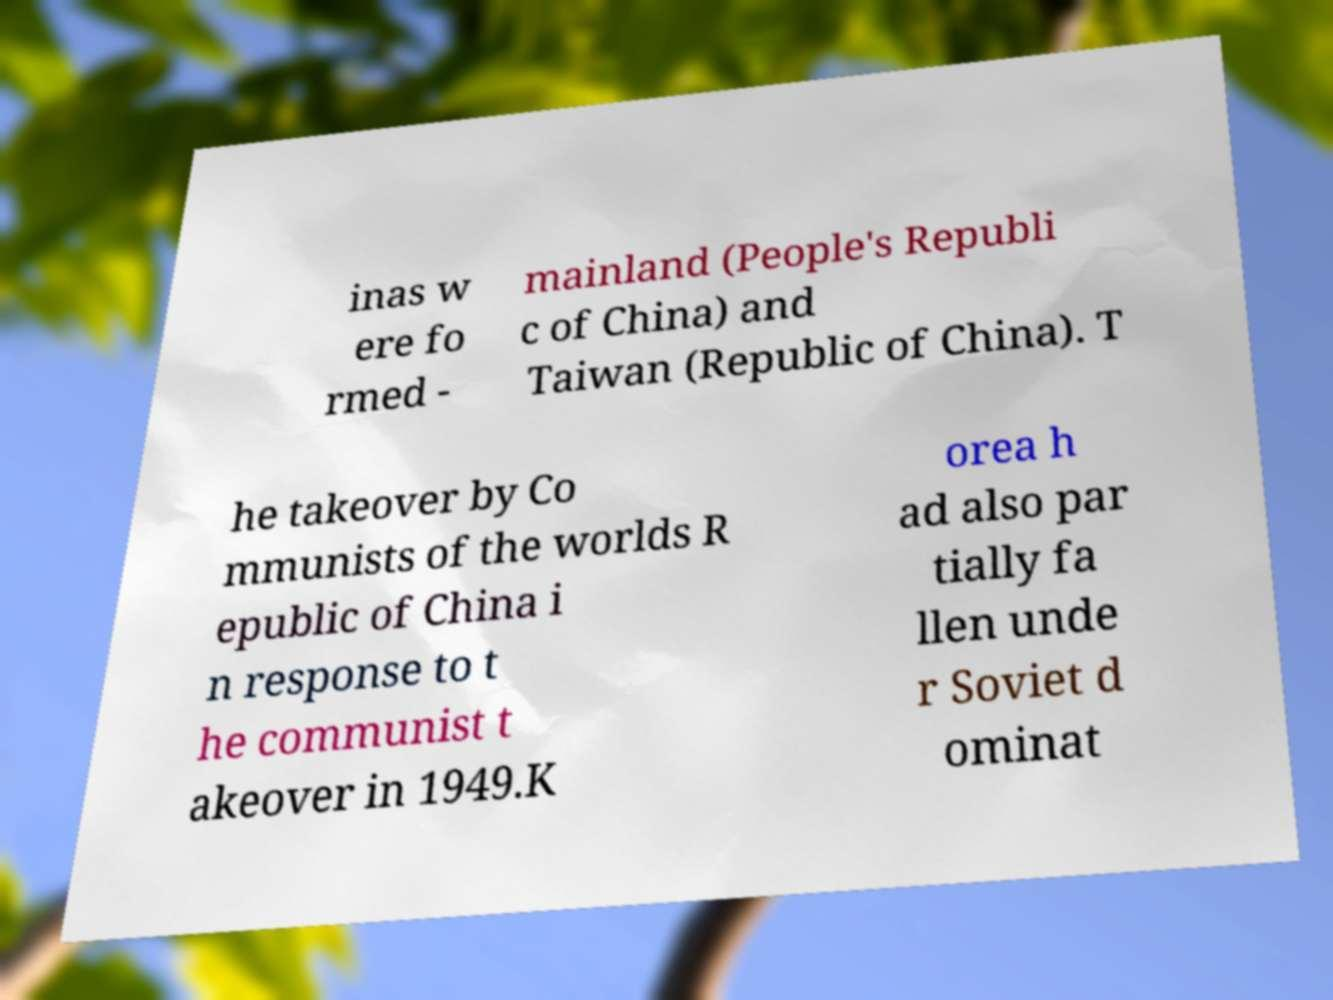Can you read and provide the text displayed in the image?This photo seems to have some interesting text. Can you extract and type it out for me? inas w ere fo rmed - mainland (People's Republi c of China) and Taiwan (Republic of China). T he takeover by Co mmunists of the worlds R epublic of China i n response to t he communist t akeover in 1949.K orea h ad also par tially fa llen unde r Soviet d ominat 